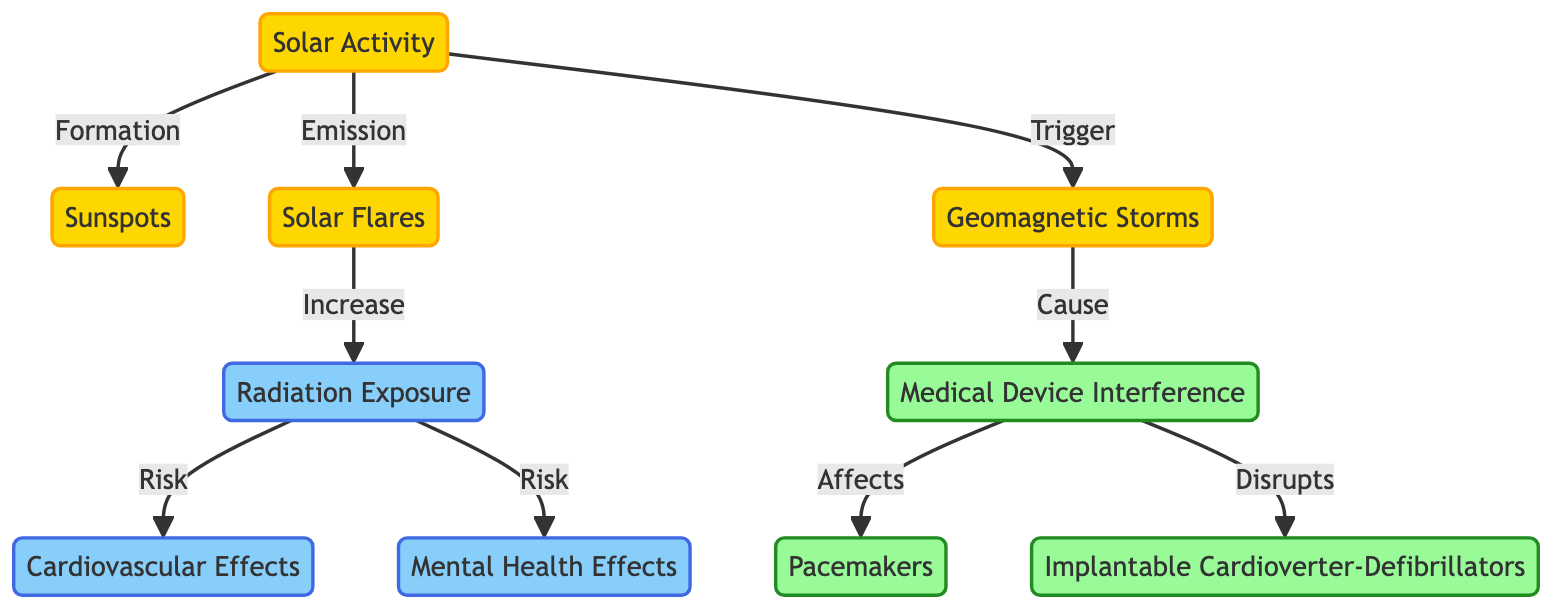What's the first node in the diagram? The first node, which represents the starting point of the flow, is "Solar Activity." It is clearly indicated at the top of the diagram as the main subject.
Answer: Solar Activity How many effects are there associated with radiation exposure in the diagram? The diagram lists two effects linked to radiation exposure: "Cardiovascular Effects" and "Mental Health Effects." By counting these nodes, we find there are two.
Answer: 2 What type of solar activity triggers geomagnetic storms? The diagram shows that geomagnetic storms are triggered by "Solar Activity." By following the directed flow from "Solar Activity" down to "Geomagnetic Storms," we see this relationship.
Answer: Solar Activity Which medical devices are affected by medical device interference caused by geomagnetic storms? The diagram indicates that "Medical Device Interference" specifically affects "Pacemakers" and "Implantable Cardioverter-Defibrillators." Both devices are listed under the affected devices node.
Answer: Pacemakers and Implantable Cardioverter-Defibrillators What do solar flares increase in terms of human health risks? According to the diagram, "Solar Flares" lead to an increase in "Radiation Exposure," which is directly connected to the health risks mentioned in the diagram. Hence, solar flares have this effect.
Answer: Radiation Exposure How does the flow in the diagram depict the relationship between solar flares and cardiovascular effects? The flow demonstrates that "Solar Flares" lead to an increase in "Radiation Exposure," which in turn poses a risk for "Cardiovascular Effects." This shows a sequential dependency: solar flares lead to radiation exposure, affecting cardiovascular health.
Answer: Through Radiation Exposure Which type of solar activity directly results in radiation exposure? The diagram illustrates that "Solar Flares" are the type of solar activity that directly leads to increased "Radiation Exposure," making this connection explicit.
Answer: Solar Flares What is the relationship type between geomagnetic storms and medical device interference? The diagram indicates that geomagnetic storms "Cause" medical device interference. The arrow pointing from "Geomagnetic Storms" to "Medical Device Interference" indicates a causative link.
Answer: Cause What are the two direct risks associated with radiation exposure shown in the diagram? The two direct risks stemming from "Radiation Exposure" are "Cardiovascular Effects" and "Mental Health Effects," as described in the connections from the radiation exposure node.
Answer: Cardiovascular Effects and Mental Health Effects 